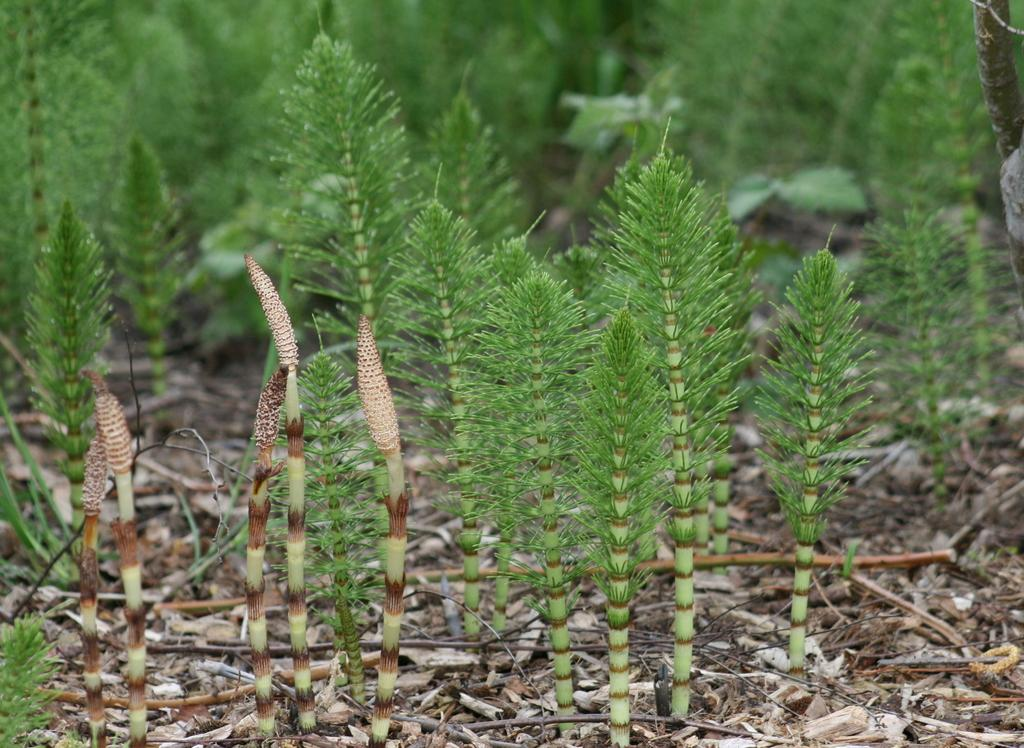What type of living organisms can be seen in the image? Plants can be seen in the image. What colors are present on the plants in the image? The plants have green, brown, and cream colors. Where are the plants located in the image? The plants are on the ground. What can be seen in the background of the image? There are trees in the background of the image. What color are the trees in the image? The trees are green in color. What type of cloth is being used to cover the quince in the image? There is no quince or cloth present in the image. What type of legal advice is the lawyer providing in the image? There is no lawyer or legal advice present in the image. 